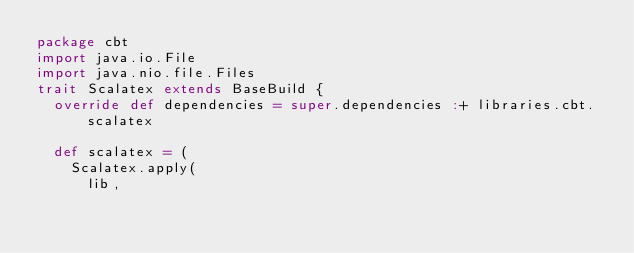Convert code to text. <code><loc_0><loc_0><loc_500><loc_500><_Scala_>package cbt
import java.io.File
import java.nio.file.Files
trait Scalatex extends BaseBuild {
  override def dependencies = super.dependencies :+ libraries.cbt.scalatex

  def scalatex = (
    Scalatex.apply(
      lib,</code> 